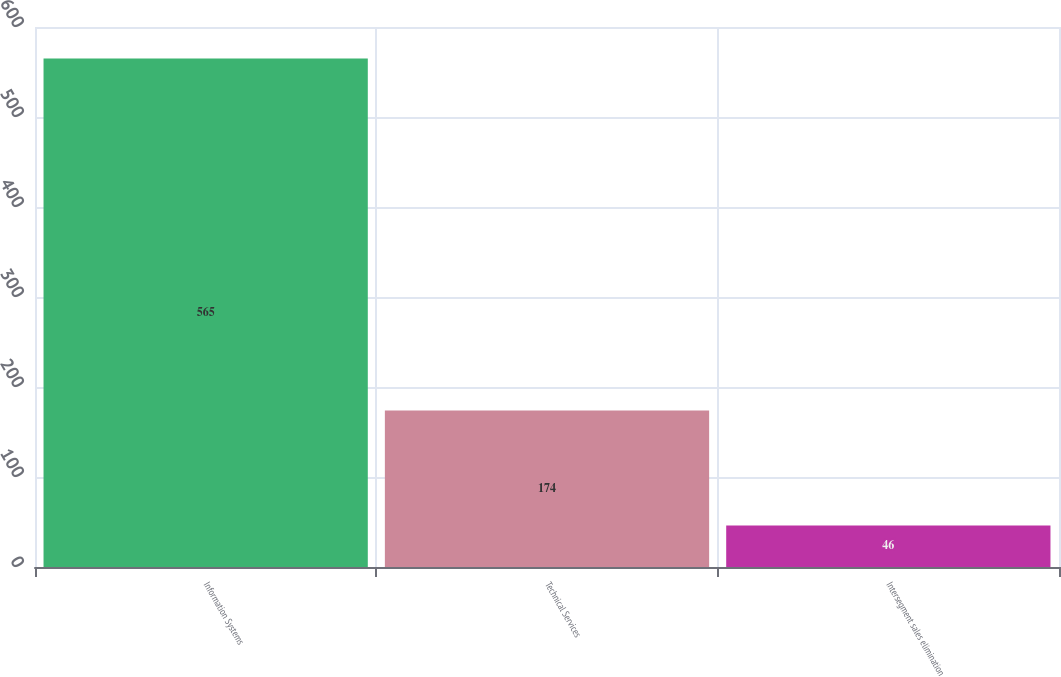<chart> <loc_0><loc_0><loc_500><loc_500><bar_chart><fcel>Information Systems<fcel>Technical Services<fcel>Intersegment sales elimination<nl><fcel>565<fcel>174<fcel>46<nl></chart> 